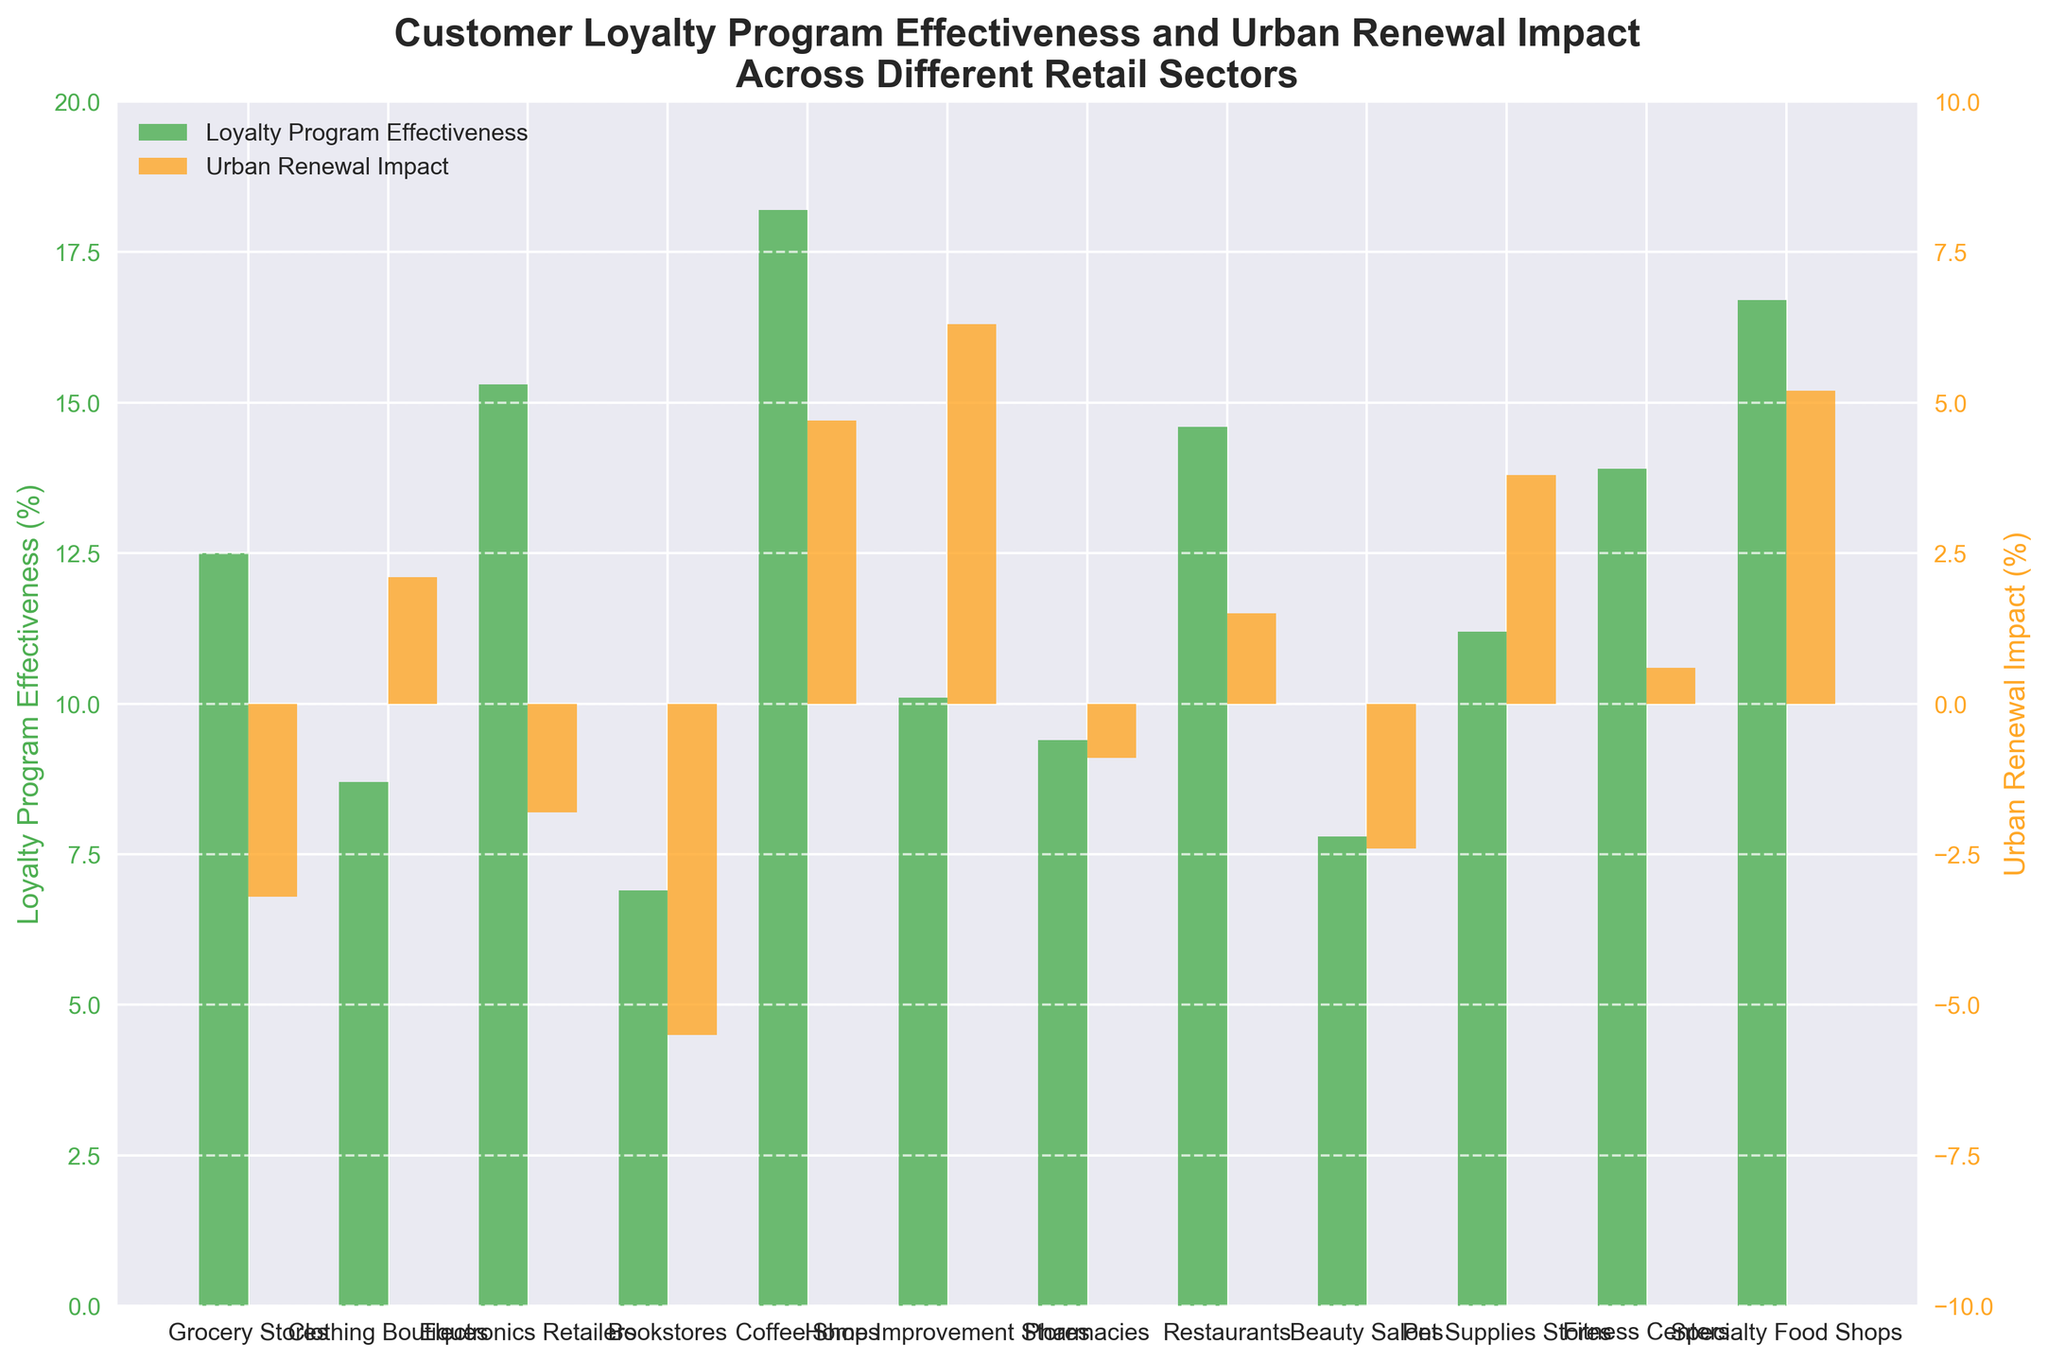Which retail sector shows the highest effectiveness of loyalty programs? The highest bar in the left (green) side represents loyalty program effectiveness for Coffee Shops.
Answer: Coffee Shops Which sector has the greatest positive urban renewal impact? The highest bar in the right (orange) side is for Home Improvement Stores.
Answer: Home Improvement Stores What is the difference in loyalty program effectiveness between Grocery Stores and Bookstores? The effectiveness for Grocery Stores is 12.5%, and for Bookstores is 6.9%. The difference is 12.5% - 6.9% = 5.6%.
Answer: 5.6% How does urban renewal impact affect Electronics Retailers compared to Pharmacies? The urban renewal impact for Electronics Retailers is -1.8% and for Pharmacies is -0.9%. The impact is less negative for Pharmacies.
Answer: Less negative for Pharmacies What is the sum of loyalty program effectiveness for Clothing Boutiques and Beauty Salons? Effectiveness for Clothing Boutiques is 8.7% and for Beauty Salons is 7.8%. Sum is 8.7% + 7.8% = 16.5%
Answer: 16.5% Which sector shows the smallest negative impact from urban renewal? The smallest negative impact on the right (orange) side is seen for Pharmacies at -0.9%.
Answer: Pharmacies Are there any sectors with both positive urban renewal impact and loyalty program effectiveness increases? Check sectors with urban renewal impact greater than 0 and increases in loyalty program effectiveness. Options include Clothing Boutiques, Coffee Shops, Home Improvement Stores, Pet Supplies Stores, Fitness Centers, Specialty Food Shops.
Answer: Clothing Boutiques, Coffee Shops, Home Improvement Stores, Pet Supplies Stores, Fitness Centers, Specialty Food Shops What is the average loyalty program effectiveness across all sectors? Sum of all effectiveness values: 12.5 + 8.7 + 15.3 + 6.9 + 18.2 + 10.1 + 9.4 + 14.6 + 7.8 + 11.2 + 13.9 + 16.7 = 145.3%. 145.3 / 12 (number of sectors) = 12.1%
Answer: 12.1% Which sectors experienced positive impact from urban renewal but less than 3%? Check bars on the right (orange) side for values between 0 and 3%. Include Clothing Boutiques (2.1%) and Restaurants (1.5%).
Answer: Clothing Boutiques, Restaurants What is the combined urban renewal impact for sectors negatively impacted? Sum negative impacts: -3.2 (Grocery Stores) -5.5 (Bookstores) -1.8 (Electronics Retailers) -0.9 (Pharmacies) -2.4 (Beauty Salons) = -13.8%
Answer: -13.8% 